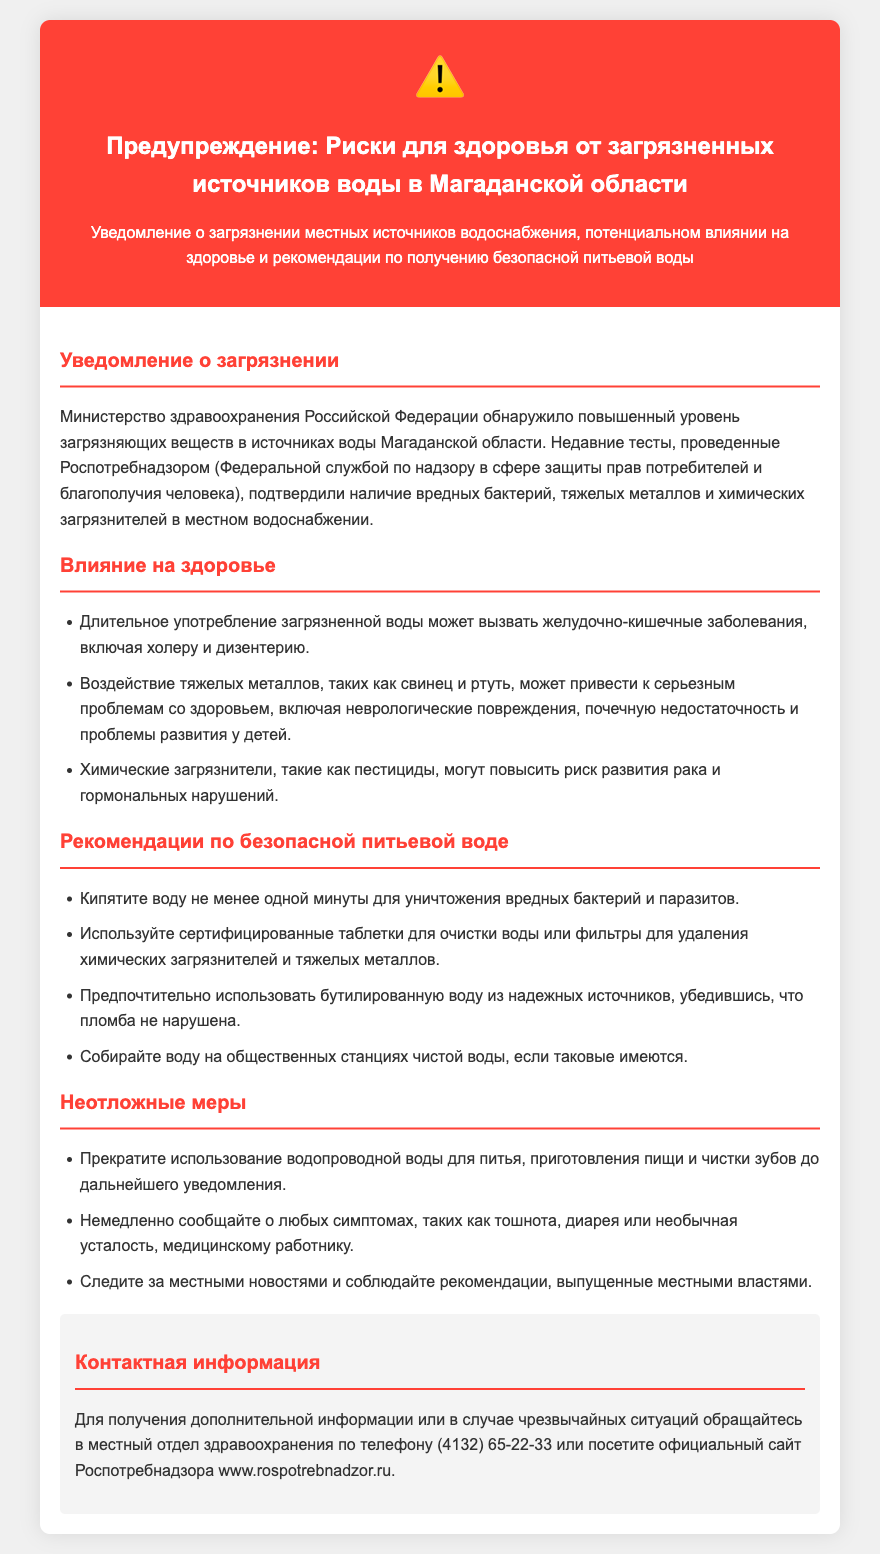Какой уровень загрязнения был обнаружен в воде Магаданской области? Согласно документу, в источниках воды обнаружен повышенный уровень загрязняющих веществ.
Answer: Повышенный уровень загрязняющих веществ Какие бактерии могут быть обнаружены в местном водоснабжении? В документе упоминаются вредные бактерии, обнаруженные в местном водоснабжении.
Answer: Вредные бактерии Что может вызвать длительное употребление загрязненной воды? Длительное употребление загрязненной воды может привести к серьезным заболеваниям, указанным в документе.
Answer: Желудочно-кишечные заболевания Какой срок кипячения воды рекомендован для уничтожения вредных бактерий? Документ указывает, что нужно кипятить воду не менее одной минуты.
Answer: Одной минуты Что делать при симптомах тошноты? На основании документа, при возникновении симптомов необходимо немедленно сообщить медицинскому работнику.
Answer: Сообщить медицинскому работнику Какую воду предпочтительно использовать для питья? В документе указано, что предпочтительно использовать бутилированную воду из надежных источников.
Answer: Бутилированную воду Какой номер телефона местного отдела здравоохранения для получения дополнительной информации? В документе представлен номер телефона для связи с местным отделом здравоохранения.
Answer: (4132) 65-22-33 Какова цель данного предупреждения? Цель предупреждения заключается в информировании о загрязнении и рекомендациях по безопасной питьевой воде.
Answer: Информирование о загрязнении и рекомендациях Какие тяжелые металлы вызывают проблемы со здоровьем? В документе названы тяжелые металлы, которые могут вызвать серьезные проблемы со здоровьем.
Answer: Свинец и ртуть 